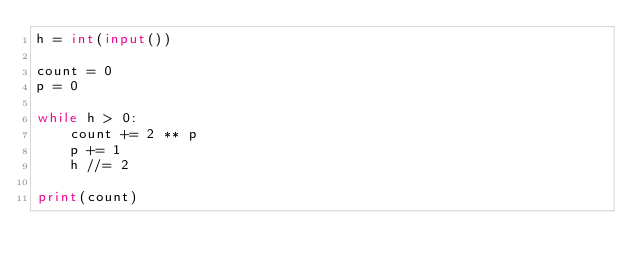<code> <loc_0><loc_0><loc_500><loc_500><_Python_>h = int(input())

count = 0
p = 0

while h > 0:
    count += 2 ** p
    p += 1
    h //= 2

print(count)
</code> 